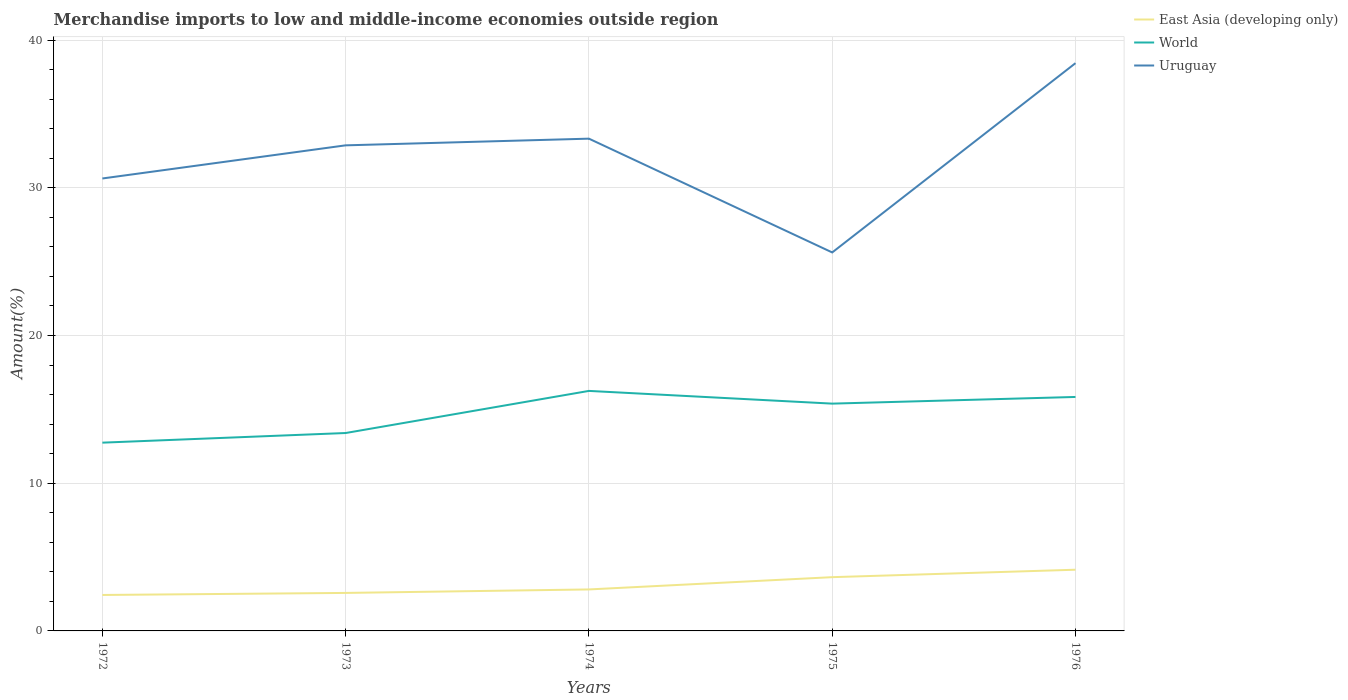Across all years, what is the maximum percentage of amount earned from merchandise imports in East Asia (developing only)?
Your response must be concise. 2.43. In which year was the percentage of amount earned from merchandise imports in Uruguay maximum?
Your response must be concise. 1975. What is the total percentage of amount earned from merchandise imports in Uruguay in the graph?
Your answer should be very brief. -5.11. What is the difference between the highest and the second highest percentage of amount earned from merchandise imports in World?
Give a very brief answer. 3.5. What is the difference between the highest and the lowest percentage of amount earned from merchandise imports in World?
Offer a very short reply. 3. Is the percentage of amount earned from merchandise imports in East Asia (developing only) strictly greater than the percentage of amount earned from merchandise imports in World over the years?
Provide a short and direct response. Yes. How many lines are there?
Provide a short and direct response. 3. How many years are there in the graph?
Your response must be concise. 5. What is the difference between two consecutive major ticks on the Y-axis?
Your answer should be compact. 10. Does the graph contain grids?
Provide a short and direct response. Yes. What is the title of the graph?
Keep it short and to the point. Merchandise imports to low and middle-income economies outside region. What is the label or title of the Y-axis?
Give a very brief answer. Amount(%). What is the Amount(%) of East Asia (developing only) in 1972?
Your answer should be compact. 2.43. What is the Amount(%) of World in 1972?
Your answer should be compact. 12.75. What is the Amount(%) in Uruguay in 1972?
Your response must be concise. 30.63. What is the Amount(%) of East Asia (developing only) in 1973?
Provide a succinct answer. 2.57. What is the Amount(%) of World in 1973?
Ensure brevity in your answer.  13.4. What is the Amount(%) in Uruguay in 1973?
Provide a succinct answer. 32.87. What is the Amount(%) in East Asia (developing only) in 1974?
Your answer should be very brief. 2.81. What is the Amount(%) of World in 1974?
Make the answer very short. 16.25. What is the Amount(%) in Uruguay in 1974?
Provide a succinct answer. 33.33. What is the Amount(%) of East Asia (developing only) in 1975?
Provide a succinct answer. 3.64. What is the Amount(%) of World in 1975?
Offer a very short reply. 15.39. What is the Amount(%) in Uruguay in 1975?
Give a very brief answer. 25.62. What is the Amount(%) of East Asia (developing only) in 1976?
Offer a terse response. 4.14. What is the Amount(%) in World in 1976?
Provide a short and direct response. 15.84. What is the Amount(%) in Uruguay in 1976?
Offer a terse response. 38.44. Across all years, what is the maximum Amount(%) in East Asia (developing only)?
Keep it short and to the point. 4.14. Across all years, what is the maximum Amount(%) in World?
Provide a short and direct response. 16.25. Across all years, what is the maximum Amount(%) in Uruguay?
Make the answer very short. 38.44. Across all years, what is the minimum Amount(%) in East Asia (developing only)?
Provide a succinct answer. 2.43. Across all years, what is the minimum Amount(%) in World?
Your answer should be compact. 12.75. Across all years, what is the minimum Amount(%) in Uruguay?
Make the answer very short. 25.62. What is the total Amount(%) of East Asia (developing only) in the graph?
Give a very brief answer. 15.6. What is the total Amount(%) of World in the graph?
Make the answer very short. 73.62. What is the total Amount(%) of Uruguay in the graph?
Ensure brevity in your answer.  160.89. What is the difference between the Amount(%) in East Asia (developing only) in 1972 and that in 1973?
Your answer should be compact. -0.14. What is the difference between the Amount(%) of World in 1972 and that in 1973?
Make the answer very short. -0.65. What is the difference between the Amount(%) in Uruguay in 1972 and that in 1973?
Provide a short and direct response. -2.24. What is the difference between the Amount(%) of East Asia (developing only) in 1972 and that in 1974?
Make the answer very short. -0.37. What is the difference between the Amount(%) of World in 1972 and that in 1974?
Your response must be concise. -3.5. What is the difference between the Amount(%) of Uruguay in 1972 and that in 1974?
Offer a very short reply. -2.7. What is the difference between the Amount(%) of East Asia (developing only) in 1972 and that in 1975?
Make the answer very short. -1.21. What is the difference between the Amount(%) in World in 1972 and that in 1975?
Offer a very short reply. -2.64. What is the difference between the Amount(%) of Uruguay in 1972 and that in 1975?
Make the answer very short. 5.01. What is the difference between the Amount(%) in East Asia (developing only) in 1972 and that in 1976?
Provide a succinct answer. -1.71. What is the difference between the Amount(%) of World in 1972 and that in 1976?
Provide a short and direct response. -3.09. What is the difference between the Amount(%) in Uruguay in 1972 and that in 1976?
Provide a short and direct response. -7.81. What is the difference between the Amount(%) in East Asia (developing only) in 1973 and that in 1974?
Your answer should be very brief. -0.24. What is the difference between the Amount(%) in World in 1973 and that in 1974?
Make the answer very short. -2.85. What is the difference between the Amount(%) in Uruguay in 1973 and that in 1974?
Make the answer very short. -0.45. What is the difference between the Amount(%) in East Asia (developing only) in 1973 and that in 1975?
Your answer should be compact. -1.07. What is the difference between the Amount(%) in World in 1973 and that in 1975?
Provide a succinct answer. -1.99. What is the difference between the Amount(%) of Uruguay in 1973 and that in 1975?
Your response must be concise. 7.25. What is the difference between the Amount(%) of East Asia (developing only) in 1973 and that in 1976?
Your response must be concise. -1.57. What is the difference between the Amount(%) in World in 1973 and that in 1976?
Offer a very short reply. -2.44. What is the difference between the Amount(%) of Uruguay in 1973 and that in 1976?
Give a very brief answer. -5.56. What is the difference between the Amount(%) of East Asia (developing only) in 1974 and that in 1975?
Give a very brief answer. -0.83. What is the difference between the Amount(%) in World in 1974 and that in 1975?
Your answer should be very brief. 0.86. What is the difference between the Amount(%) of Uruguay in 1974 and that in 1975?
Ensure brevity in your answer.  7.7. What is the difference between the Amount(%) in East Asia (developing only) in 1974 and that in 1976?
Provide a succinct answer. -1.33. What is the difference between the Amount(%) in World in 1974 and that in 1976?
Keep it short and to the point. 0.41. What is the difference between the Amount(%) of Uruguay in 1974 and that in 1976?
Offer a very short reply. -5.11. What is the difference between the Amount(%) in East Asia (developing only) in 1975 and that in 1976?
Provide a succinct answer. -0.5. What is the difference between the Amount(%) of World in 1975 and that in 1976?
Make the answer very short. -0.45. What is the difference between the Amount(%) of Uruguay in 1975 and that in 1976?
Your answer should be very brief. -12.81. What is the difference between the Amount(%) of East Asia (developing only) in 1972 and the Amount(%) of World in 1973?
Keep it short and to the point. -10.96. What is the difference between the Amount(%) in East Asia (developing only) in 1972 and the Amount(%) in Uruguay in 1973?
Ensure brevity in your answer.  -30.44. What is the difference between the Amount(%) in World in 1972 and the Amount(%) in Uruguay in 1973?
Provide a succinct answer. -20.13. What is the difference between the Amount(%) of East Asia (developing only) in 1972 and the Amount(%) of World in 1974?
Give a very brief answer. -13.82. What is the difference between the Amount(%) in East Asia (developing only) in 1972 and the Amount(%) in Uruguay in 1974?
Your answer should be very brief. -30.89. What is the difference between the Amount(%) of World in 1972 and the Amount(%) of Uruguay in 1974?
Provide a short and direct response. -20.58. What is the difference between the Amount(%) of East Asia (developing only) in 1972 and the Amount(%) of World in 1975?
Your response must be concise. -12.95. What is the difference between the Amount(%) of East Asia (developing only) in 1972 and the Amount(%) of Uruguay in 1975?
Offer a very short reply. -23.19. What is the difference between the Amount(%) of World in 1972 and the Amount(%) of Uruguay in 1975?
Ensure brevity in your answer.  -12.88. What is the difference between the Amount(%) in East Asia (developing only) in 1972 and the Amount(%) in World in 1976?
Your answer should be compact. -13.41. What is the difference between the Amount(%) of East Asia (developing only) in 1972 and the Amount(%) of Uruguay in 1976?
Offer a very short reply. -36. What is the difference between the Amount(%) of World in 1972 and the Amount(%) of Uruguay in 1976?
Provide a short and direct response. -25.69. What is the difference between the Amount(%) in East Asia (developing only) in 1973 and the Amount(%) in World in 1974?
Provide a short and direct response. -13.68. What is the difference between the Amount(%) of East Asia (developing only) in 1973 and the Amount(%) of Uruguay in 1974?
Offer a terse response. -30.75. What is the difference between the Amount(%) in World in 1973 and the Amount(%) in Uruguay in 1974?
Give a very brief answer. -19.93. What is the difference between the Amount(%) in East Asia (developing only) in 1973 and the Amount(%) in World in 1975?
Provide a short and direct response. -12.82. What is the difference between the Amount(%) of East Asia (developing only) in 1973 and the Amount(%) of Uruguay in 1975?
Offer a terse response. -23.05. What is the difference between the Amount(%) of World in 1973 and the Amount(%) of Uruguay in 1975?
Offer a very short reply. -12.22. What is the difference between the Amount(%) of East Asia (developing only) in 1973 and the Amount(%) of World in 1976?
Offer a terse response. -13.27. What is the difference between the Amount(%) of East Asia (developing only) in 1973 and the Amount(%) of Uruguay in 1976?
Make the answer very short. -35.86. What is the difference between the Amount(%) of World in 1973 and the Amount(%) of Uruguay in 1976?
Ensure brevity in your answer.  -25.04. What is the difference between the Amount(%) of East Asia (developing only) in 1974 and the Amount(%) of World in 1975?
Your answer should be compact. -12.58. What is the difference between the Amount(%) in East Asia (developing only) in 1974 and the Amount(%) in Uruguay in 1975?
Offer a terse response. -22.81. What is the difference between the Amount(%) of World in 1974 and the Amount(%) of Uruguay in 1975?
Your answer should be compact. -9.37. What is the difference between the Amount(%) of East Asia (developing only) in 1974 and the Amount(%) of World in 1976?
Make the answer very short. -13.03. What is the difference between the Amount(%) of East Asia (developing only) in 1974 and the Amount(%) of Uruguay in 1976?
Your answer should be very brief. -35.63. What is the difference between the Amount(%) in World in 1974 and the Amount(%) in Uruguay in 1976?
Offer a very short reply. -22.19. What is the difference between the Amount(%) in East Asia (developing only) in 1975 and the Amount(%) in World in 1976?
Offer a terse response. -12.2. What is the difference between the Amount(%) of East Asia (developing only) in 1975 and the Amount(%) of Uruguay in 1976?
Give a very brief answer. -34.8. What is the difference between the Amount(%) of World in 1975 and the Amount(%) of Uruguay in 1976?
Provide a succinct answer. -23.05. What is the average Amount(%) in East Asia (developing only) per year?
Offer a very short reply. 3.12. What is the average Amount(%) of World per year?
Your answer should be very brief. 14.72. What is the average Amount(%) of Uruguay per year?
Provide a short and direct response. 32.18. In the year 1972, what is the difference between the Amount(%) of East Asia (developing only) and Amount(%) of World?
Give a very brief answer. -10.31. In the year 1972, what is the difference between the Amount(%) of East Asia (developing only) and Amount(%) of Uruguay?
Your response must be concise. -28.2. In the year 1972, what is the difference between the Amount(%) in World and Amount(%) in Uruguay?
Your answer should be very brief. -17.88. In the year 1973, what is the difference between the Amount(%) in East Asia (developing only) and Amount(%) in World?
Your answer should be very brief. -10.83. In the year 1973, what is the difference between the Amount(%) in East Asia (developing only) and Amount(%) in Uruguay?
Your answer should be compact. -30.3. In the year 1973, what is the difference between the Amount(%) of World and Amount(%) of Uruguay?
Make the answer very short. -19.48. In the year 1974, what is the difference between the Amount(%) of East Asia (developing only) and Amount(%) of World?
Provide a short and direct response. -13.44. In the year 1974, what is the difference between the Amount(%) in East Asia (developing only) and Amount(%) in Uruguay?
Provide a short and direct response. -30.52. In the year 1974, what is the difference between the Amount(%) in World and Amount(%) in Uruguay?
Provide a short and direct response. -17.08. In the year 1975, what is the difference between the Amount(%) of East Asia (developing only) and Amount(%) of World?
Provide a short and direct response. -11.75. In the year 1975, what is the difference between the Amount(%) of East Asia (developing only) and Amount(%) of Uruguay?
Give a very brief answer. -21.98. In the year 1975, what is the difference between the Amount(%) of World and Amount(%) of Uruguay?
Offer a very short reply. -10.23. In the year 1976, what is the difference between the Amount(%) of East Asia (developing only) and Amount(%) of World?
Keep it short and to the point. -11.7. In the year 1976, what is the difference between the Amount(%) in East Asia (developing only) and Amount(%) in Uruguay?
Make the answer very short. -34.29. In the year 1976, what is the difference between the Amount(%) of World and Amount(%) of Uruguay?
Offer a terse response. -22.6. What is the ratio of the Amount(%) in East Asia (developing only) in 1972 to that in 1973?
Your response must be concise. 0.95. What is the ratio of the Amount(%) in World in 1972 to that in 1973?
Ensure brevity in your answer.  0.95. What is the ratio of the Amount(%) of Uruguay in 1972 to that in 1973?
Your answer should be very brief. 0.93. What is the ratio of the Amount(%) in East Asia (developing only) in 1972 to that in 1974?
Offer a very short reply. 0.87. What is the ratio of the Amount(%) in World in 1972 to that in 1974?
Offer a terse response. 0.78. What is the ratio of the Amount(%) of Uruguay in 1972 to that in 1974?
Your answer should be compact. 0.92. What is the ratio of the Amount(%) of East Asia (developing only) in 1972 to that in 1975?
Your response must be concise. 0.67. What is the ratio of the Amount(%) in World in 1972 to that in 1975?
Make the answer very short. 0.83. What is the ratio of the Amount(%) of Uruguay in 1972 to that in 1975?
Provide a succinct answer. 1.2. What is the ratio of the Amount(%) of East Asia (developing only) in 1972 to that in 1976?
Your answer should be compact. 0.59. What is the ratio of the Amount(%) in World in 1972 to that in 1976?
Provide a short and direct response. 0.8. What is the ratio of the Amount(%) of Uruguay in 1972 to that in 1976?
Provide a short and direct response. 0.8. What is the ratio of the Amount(%) of East Asia (developing only) in 1973 to that in 1974?
Offer a very short reply. 0.92. What is the ratio of the Amount(%) in World in 1973 to that in 1974?
Keep it short and to the point. 0.82. What is the ratio of the Amount(%) in Uruguay in 1973 to that in 1974?
Give a very brief answer. 0.99. What is the ratio of the Amount(%) in East Asia (developing only) in 1973 to that in 1975?
Give a very brief answer. 0.71. What is the ratio of the Amount(%) of World in 1973 to that in 1975?
Make the answer very short. 0.87. What is the ratio of the Amount(%) of Uruguay in 1973 to that in 1975?
Provide a short and direct response. 1.28. What is the ratio of the Amount(%) in East Asia (developing only) in 1973 to that in 1976?
Make the answer very short. 0.62. What is the ratio of the Amount(%) in World in 1973 to that in 1976?
Ensure brevity in your answer.  0.85. What is the ratio of the Amount(%) of Uruguay in 1973 to that in 1976?
Offer a very short reply. 0.86. What is the ratio of the Amount(%) in East Asia (developing only) in 1974 to that in 1975?
Provide a succinct answer. 0.77. What is the ratio of the Amount(%) of World in 1974 to that in 1975?
Give a very brief answer. 1.06. What is the ratio of the Amount(%) in Uruguay in 1974 to that in 1975?
Offer a terse response. 1.3. What is the ratio of the Amount(%) in East Asia (developing only) in 1974 to that in 1976?
Your answer should be very brief. 0.68. What is the ratio of the Amount(%) of World in 1974 to that in 1976?
Offer a terse response. 1.03. What is the ratio of the Amount(%) of Uruguay in 1974 to that in 1976?
Offer a very short reply. 0.87. What is the ratio of the Amount(%) in East Asia (developing only) in 1975 to that in 1976?
Offer a very short reply. 0.88. What is the ratio of the Amount(%) of World in 1975 to that in 1976?
Offer a very short reply. 0.97. What is the ratio of the Amount(%) of Uruguay in 1975 to that in 1976?
Keep it short and to the point. 0.67. What is the difference between the highest and the second highest Amount(%) of East Asia (developing only)?
Offer a very short reply. 0.5. What is the difference between the highest and the second highest Amount(%) of World?
Your answer should be very brief. 0.41. What is the difference between the highest and the second highest Amount(%) in Uruguay?
Ensure brevity in your answer.  5.11. What is the difference between the highest and the lowest Amount(%) of East Asia (developing only)?
Your answer should be compact. 1.71. What is the difference between the highest and the lowest Amount(%) in World?
Offer a very short reply. 3.5. What is the difference between the highest and the lowest Amount(%) in Uruguay?
Offer a very short reply. 12.81. 